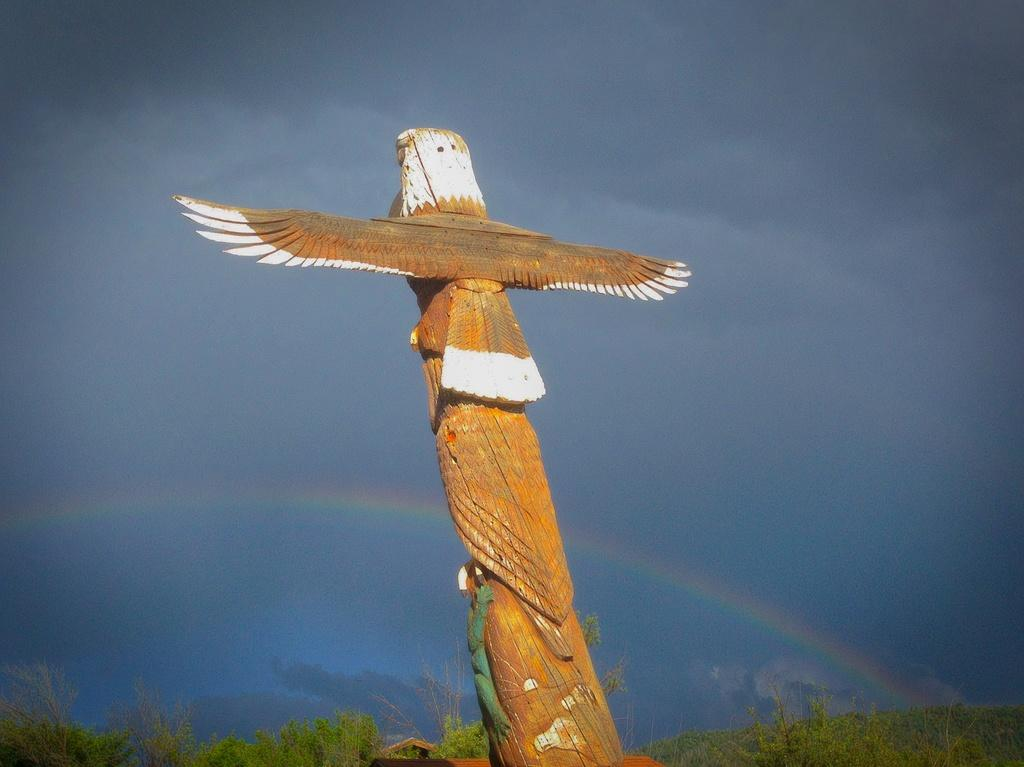What is the main subject in the center of the image? There is a wooden bird in the center of the image. What can be seen at the bottom of the image? There are plants at the bottom of the image. What is visible in the background of the image? There is a rainbow in the background of the image. What is visible at the top of the image? The sky is visible at the top of the image. What type of discovery was made during the birthday celebration in the image? There is no mention of a birthday celebration or any discovery in the image. The image features a wooden bird, plants, a rainbow, and the sky. 